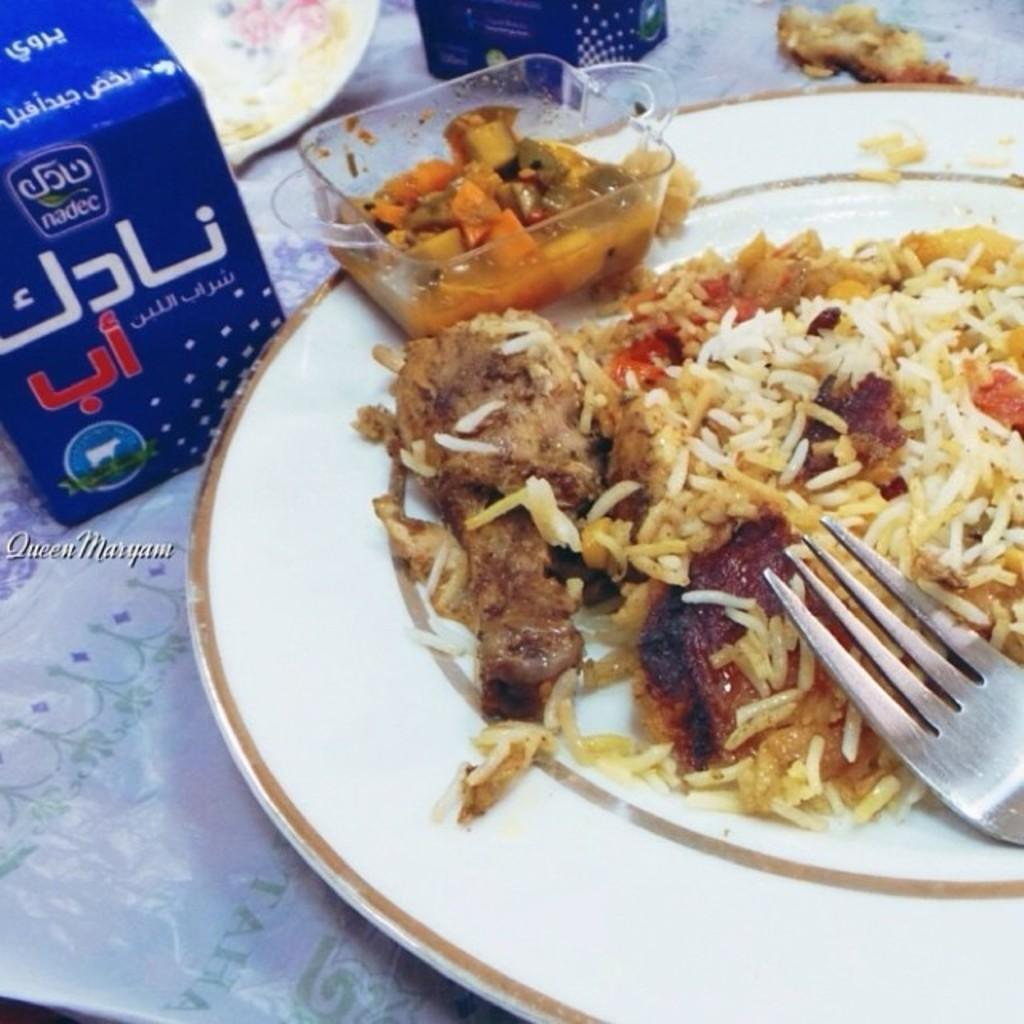What is on the plate in the image? There is food in the plate in the image. What utensil is visible in the image? There is a fork visible in the image. What can be seen in the background of the image? There is a blue box in the background of the image. What type of curtain is hanging in the image? There is no curtain present in the image. What is the sum of the food and the fork in the image? The question is not applicable, as we are not asked to perform any mathematical operations on the objects in the image. 